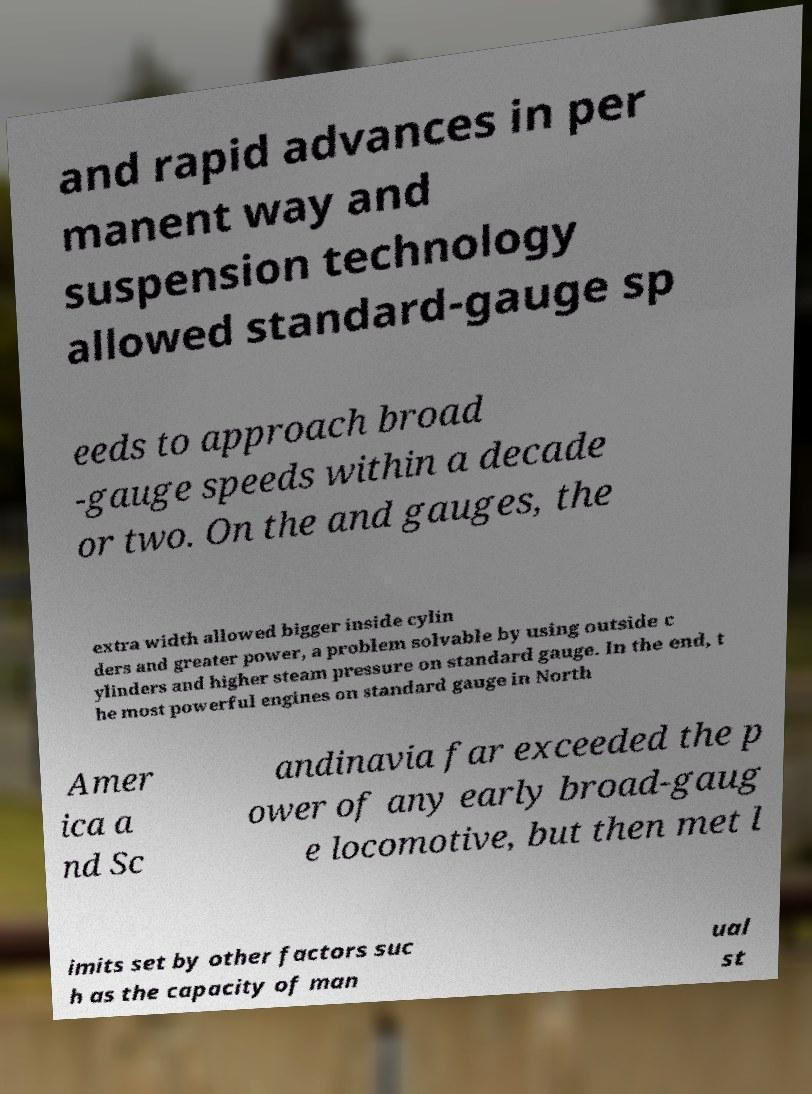What messages or text are displayed in this image? I need them in a readable, typed format. and rapid advances in per manent way and suspension technology allowed standard-gauge sp eeds to approach broad -gauge speeds within a decade or two. On the and gauges, the extra width allowed bigger inside cylin ders and greater power, a problem solvable by using outside c ylinders and higher steam pressure on standard gauge. In the end, t he most powerful engines on standard gauge in North Amer ica a nd Sc andinavia far exceeded the p ower of any early broad-gaug e locomotive, but then met l imits set by other factors suc h as the capacity of man ual st 